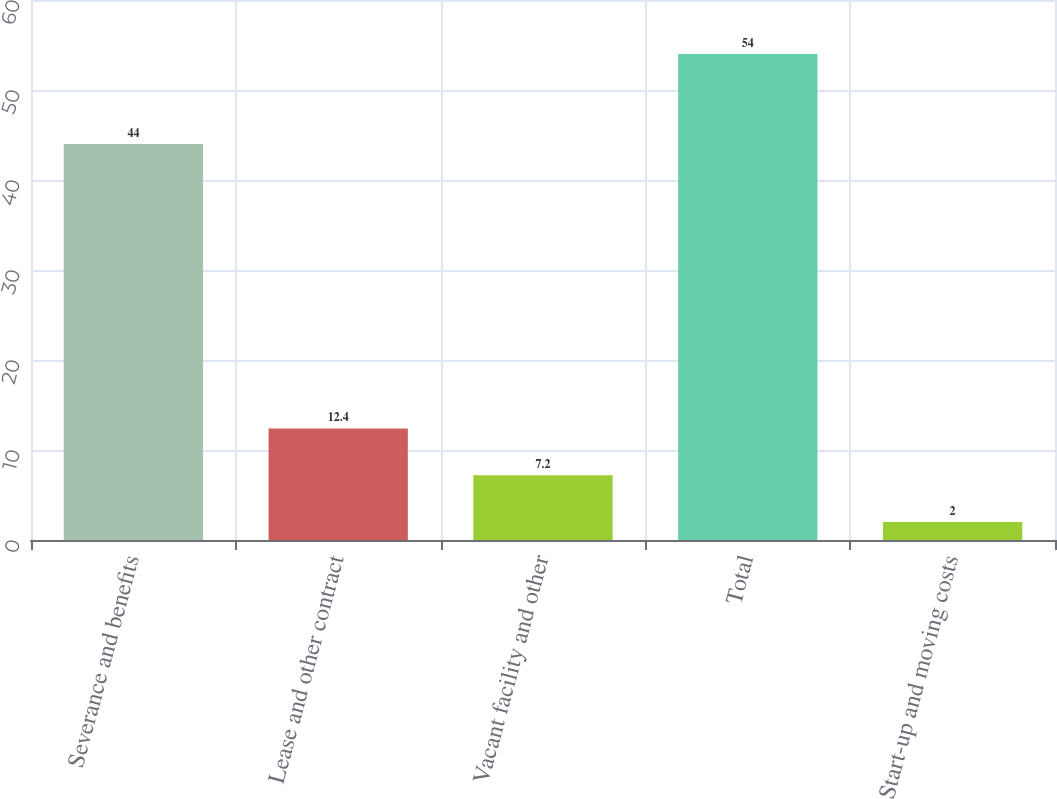<chart> <loc_0><loc_0><loc_500><loc_500><bar_chart><fcel>Severance and benefits<fcel>Lease and other contract<fcel>Vacant facility and other<fcel>Total<fcel>Start-up and moving costs<nl><fcel>44<fcel>12.4<fcel>7.2<fcel>54<fcel>2<nl></chart> 